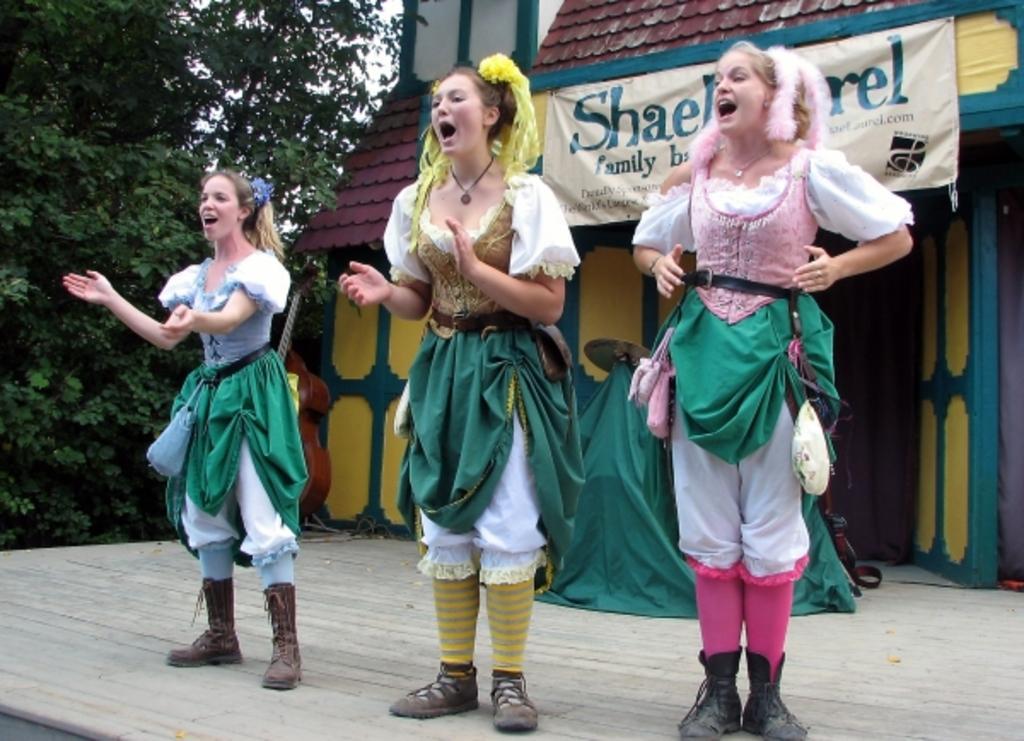How would you summarize this image in a sentence or two? In this image I can see three persons standing. In front the person is wearing gold, green and white color dress. Background I can see a banner in white color and I can also see the building in yellow and green color, trees in green color and the sky is in white color. 